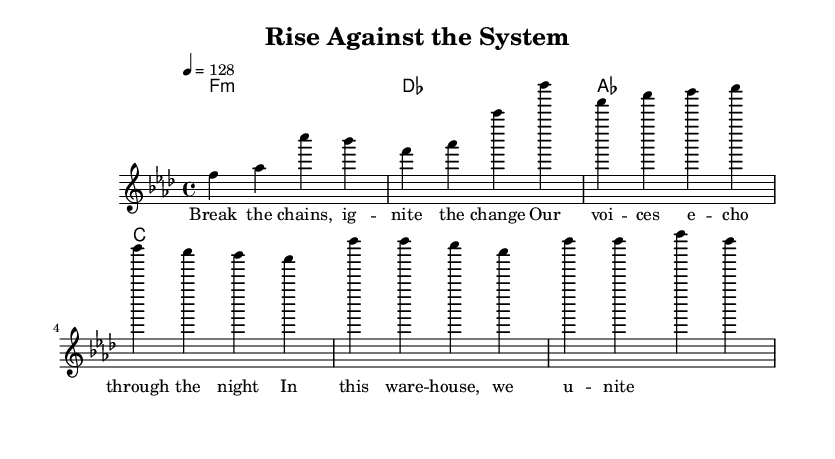What is the key signature of this music? The key signature is indicated by the presence of flat signs at the beginning of the staff. In this case, it shows B flat and E flat. Therefore, the key is F minor.
Answer: F minor What is the time signature of this music? The time signature is found at the beginning of the score, showing two numbers stacked vertically. The top number, 4, indicates there are four beats per measure, and the bottom number, 4, indicates that a quarter note gets one beat.
Answer: 4/4 What is the tempo marking for this piece? The tempo is typically indicated at the beginning of the score. Here, it's stated as "4 = 128," meaning there are 128 beats per minute, and each beat corresponds to a quarter note.
Answer: 128 What is the first chord of the harmony? The first chord in the harmony section is shown at the start where the chord is labeled as F minor, which can be inferred from the notation.
Answer: F minor How many measures are in the verse section? By counting the measures in the melody section, we see there are four distinct measures that make up the verse.
Answer: 4 What is the primary theme of the lyrics? The lyrics emphasize empowerment and unity, as indicated in phrases such as "Break the chains" and "we unite," suggesting a call to action for collective resistance.
Answer: Empowerment and unity What style does this music belong to? The overall rhythmic structure, the use of beat drops, and the electronic influences in the composition suggest this piece falls under the House music genre.
Answer: House 